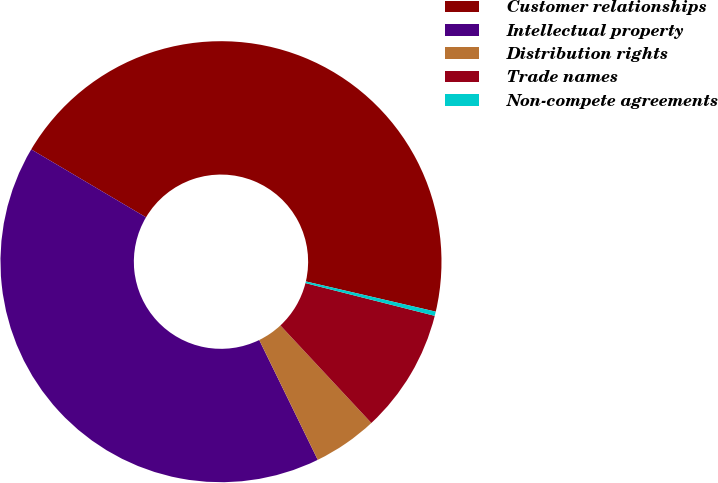<chart> <loc_0><loc_0><loc_500><loc_500><pie_chart><fcel>Customer relationships<fcel>Intellectual property<fcel>Distribution rights<fcel>Trade names<fcel>Non-compete agreements<nl><fcel>45.13%<fcel>40.73%<fcel>4.71%<fcel>9.11%<fcel>0.31%<nl></chart> 